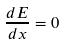<formula> <loc_0><loc_0><loc_500><loc_500>\frac { d E } { d x } = 0</formula> 